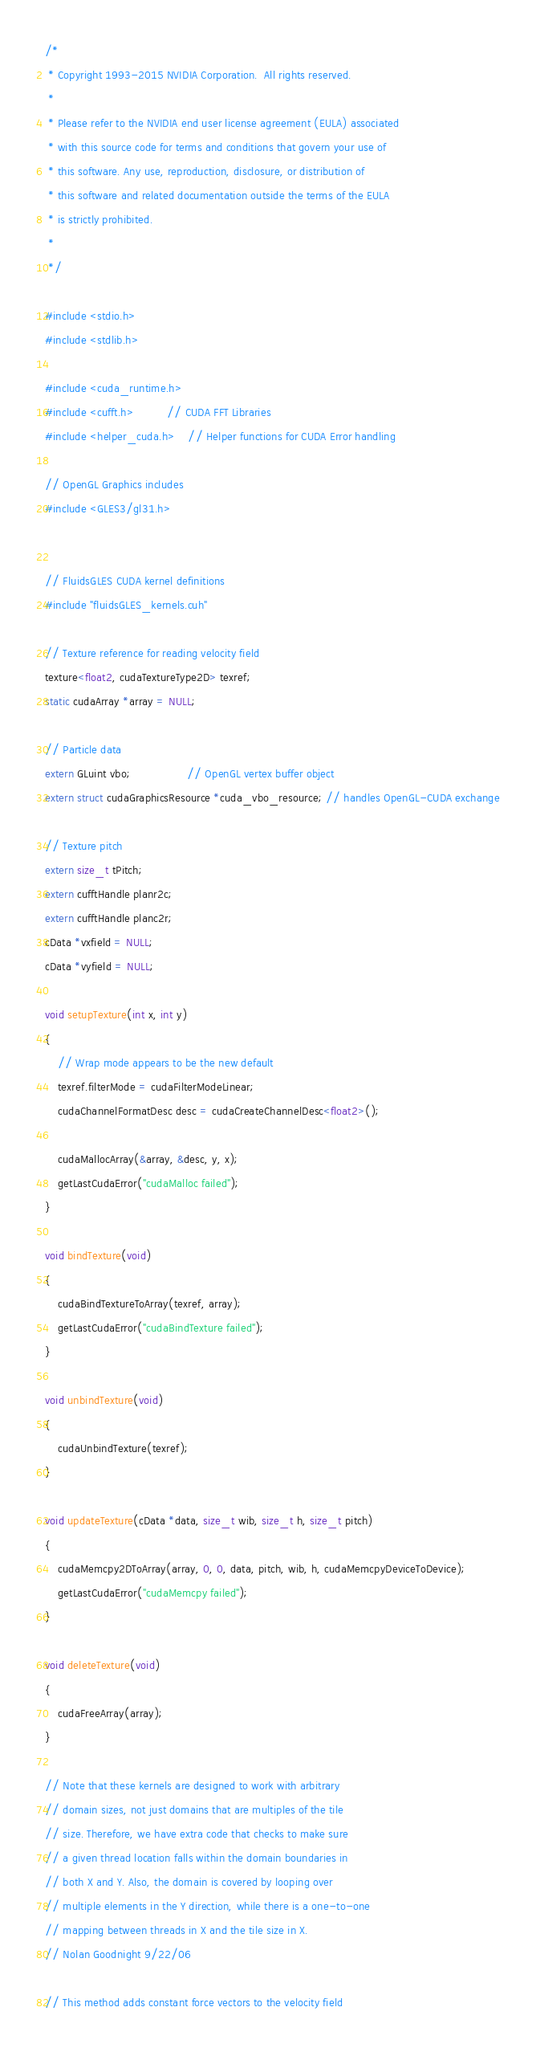<code> <loc_0><loc_0><loc_500><loc_500><_Cuda_>/*
 * Copyright 1993-2015 NVIDIA Corporation.  All rights reserved.
 *
 * Please refer to the NVIDIA end user license agreement (EULA) associated
 * with this source code for terms and conditions that govern your use of
 * this software. Any use, reproduction, disclosure, or distribution of
 * this software and related documentation outside the terms of the EULA
 * is strictly prohibited.
 *
 */

#include <stdio.h>
#include <stdlib.h>

#include <cuda_runtime.h>
#include <cufft.h>          // CUDA FFT Libraries
#include <helper_cuda.h>    // Helper functions for CUDA Error handling

// OpenGL Graphics includes
#include <GLES3/gl31.h>


// FluidsGLES CUDA kernel definitions
#include "fluidsGLES_kernels.cuh"

// Texture reference for reading velocity field
texture<float2, cudaTextureType2D> texref;
static cudaArray *array = NULL;

// Particle data
extern GLuint vbo;                 // OpenGL vertex buffer object
extern struct cudaGraphicsResource *cuda_vbo_resource; // handles OpenGL-CUDA exchange

// Texture pitch
extern size_t tPitch;
extern cufftHandle planr2c;
extern cufftHandle planc2r;
cData *vxfield = NULL;
cData *vyfield = NULL;

void setupTexture(int x, int y)
{
    // Wrap mode appears to be the new default
    texref.filterMode = cudaFilterModeLinear;
    cudaChannelFormatDesc desc = cudaCreateChannelDesc<float2>();

    cudaMallocArray(&array, &desc, y, x);
    getLastCudaError("cudaMalloc failed");
}

void bindTexture(void)
{
    cudaBindTextureToArray(texref, array);
    getLastCudaError("cudaBindTexture failed");
}

void unbindTexture(void)
{
    cudaUnbindTexture(texref);
}

void updateTexture(cData *data, size_t wib, size_t h, size_t pitch)
{
    cudaMemcpy2DToArray(array, 0, 0, data, pitch, wib, h, cudaMemcpyDeviceToDevice);
    getLastCudaError("cudaMemcpy failed");
}

void deleteTexture(void)
{
    cudaFreeArray(array);
}

// Note that these kernels are designed to work with arbitrary
// domain sizes, not just domains that are multiples of the tile
// size. Therefore, we have extra code that checks to make sure
// a given thread location falls within the domain boundaries in
// both X and Y. Also, the domain is covered by looping over
// multiple elements in the Y direction, while there is a one-to-one
// mapping between threads in X and the tile size in X.
// Nolan Goodnight 9/22/06

// This method adds constant force vectors to the velocity field</code> 